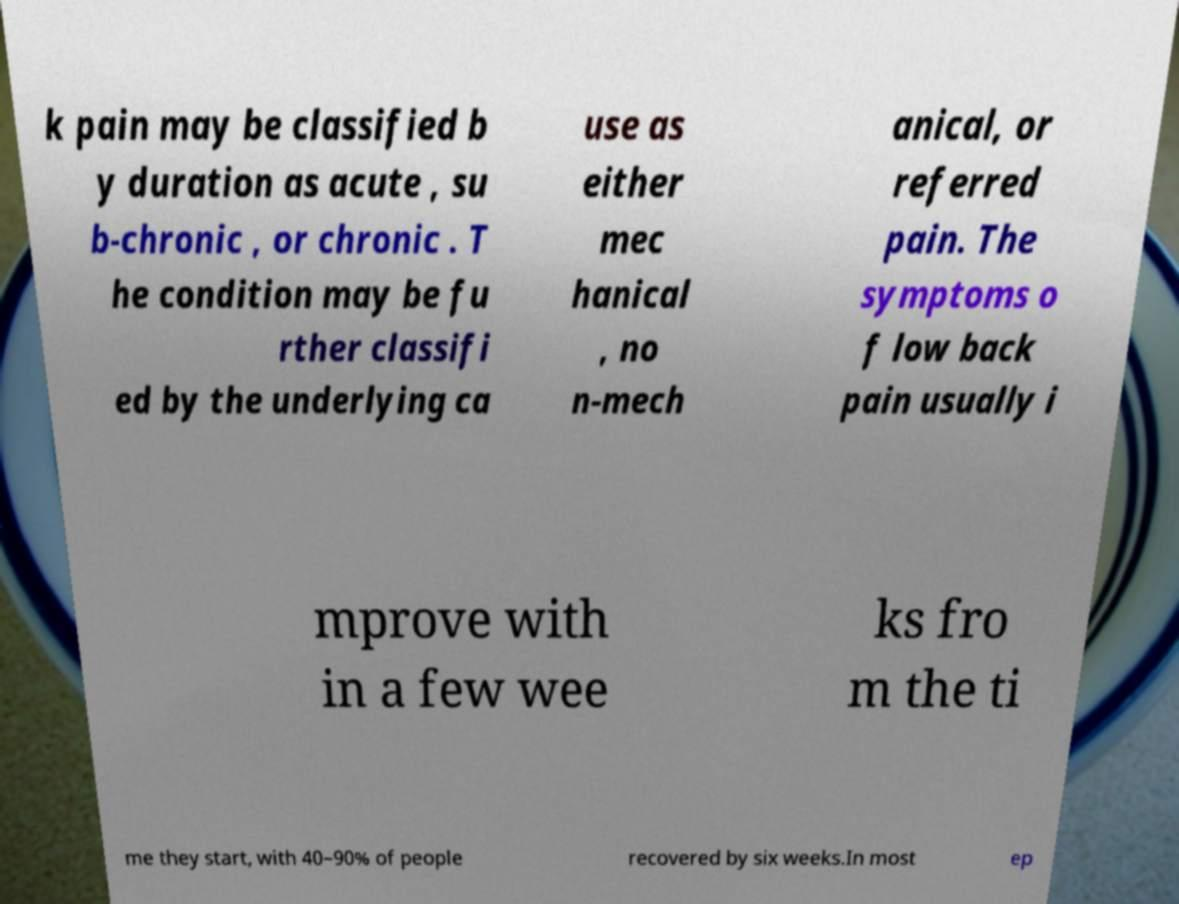What messages or text are displayed in this image? I need them in a readable, typed format. k pain may be classified b y duration as acute , su b-chronic , or chronic . T he condition may be fu rther classifi ed by the underlying ca use as either mec hanical , no n-mech anical, or referred pain. The symptoms o f low back pain usually i mprove with in a few wee ks fro m the ti me they start, with 40–90% of people recovered by six weeks.In most ep 